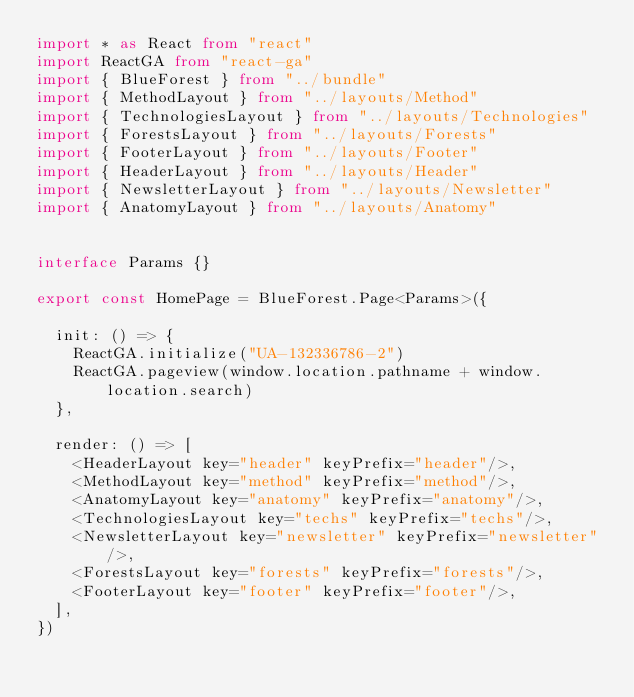<code> <loc_0><loc_0><loc_500><loc_500><_TypeScript_>import * as React from "react"
import ReactGA from "react-ga"
import { BlueForest } from "../bundle"
import { MethodLayout } from "../layouts/Method"
import { TechnologiesLayout } from "../layouts/Technologies"
import { ForestsLayout } from "../layouts/Forests"
import { FooterLayout } from "../layouts/Footer"
import { HeaderLayout } from "../layouts/Header"
import { NewsletterLayout } from "../layouts/Newsletter"
import { AnatomyLayout } from "../layouts/Anatomy"


interface Params {}

export const HomePage = BlueForest.Page<Params>({

  init: () => {
    ReactGA.initialize("UA-132336786-2")
    ReactGA.pageview(window.location.pathname + window.location.search)
  },

  render: () => [
    <HeaderLayout key="header" keyPrefix="header"/>,
    <MethodLayout key="method" keyPrefix="method"/>,
    <AnatomyLayout key="anatomy" keyPrefix="anatomy"/>,
    <TechnologiesLayout key="techs" keyPrefix="techs"/>,
    <NewsletterLayout key="newsletter" keyPrefix="newsletter"/>,
    <ForestsLayout key="forests" keyPrefix="forests"/>,
    <FooterLayout key="footer" keyPrefix="footer"/>,
  ],
})
</code> 